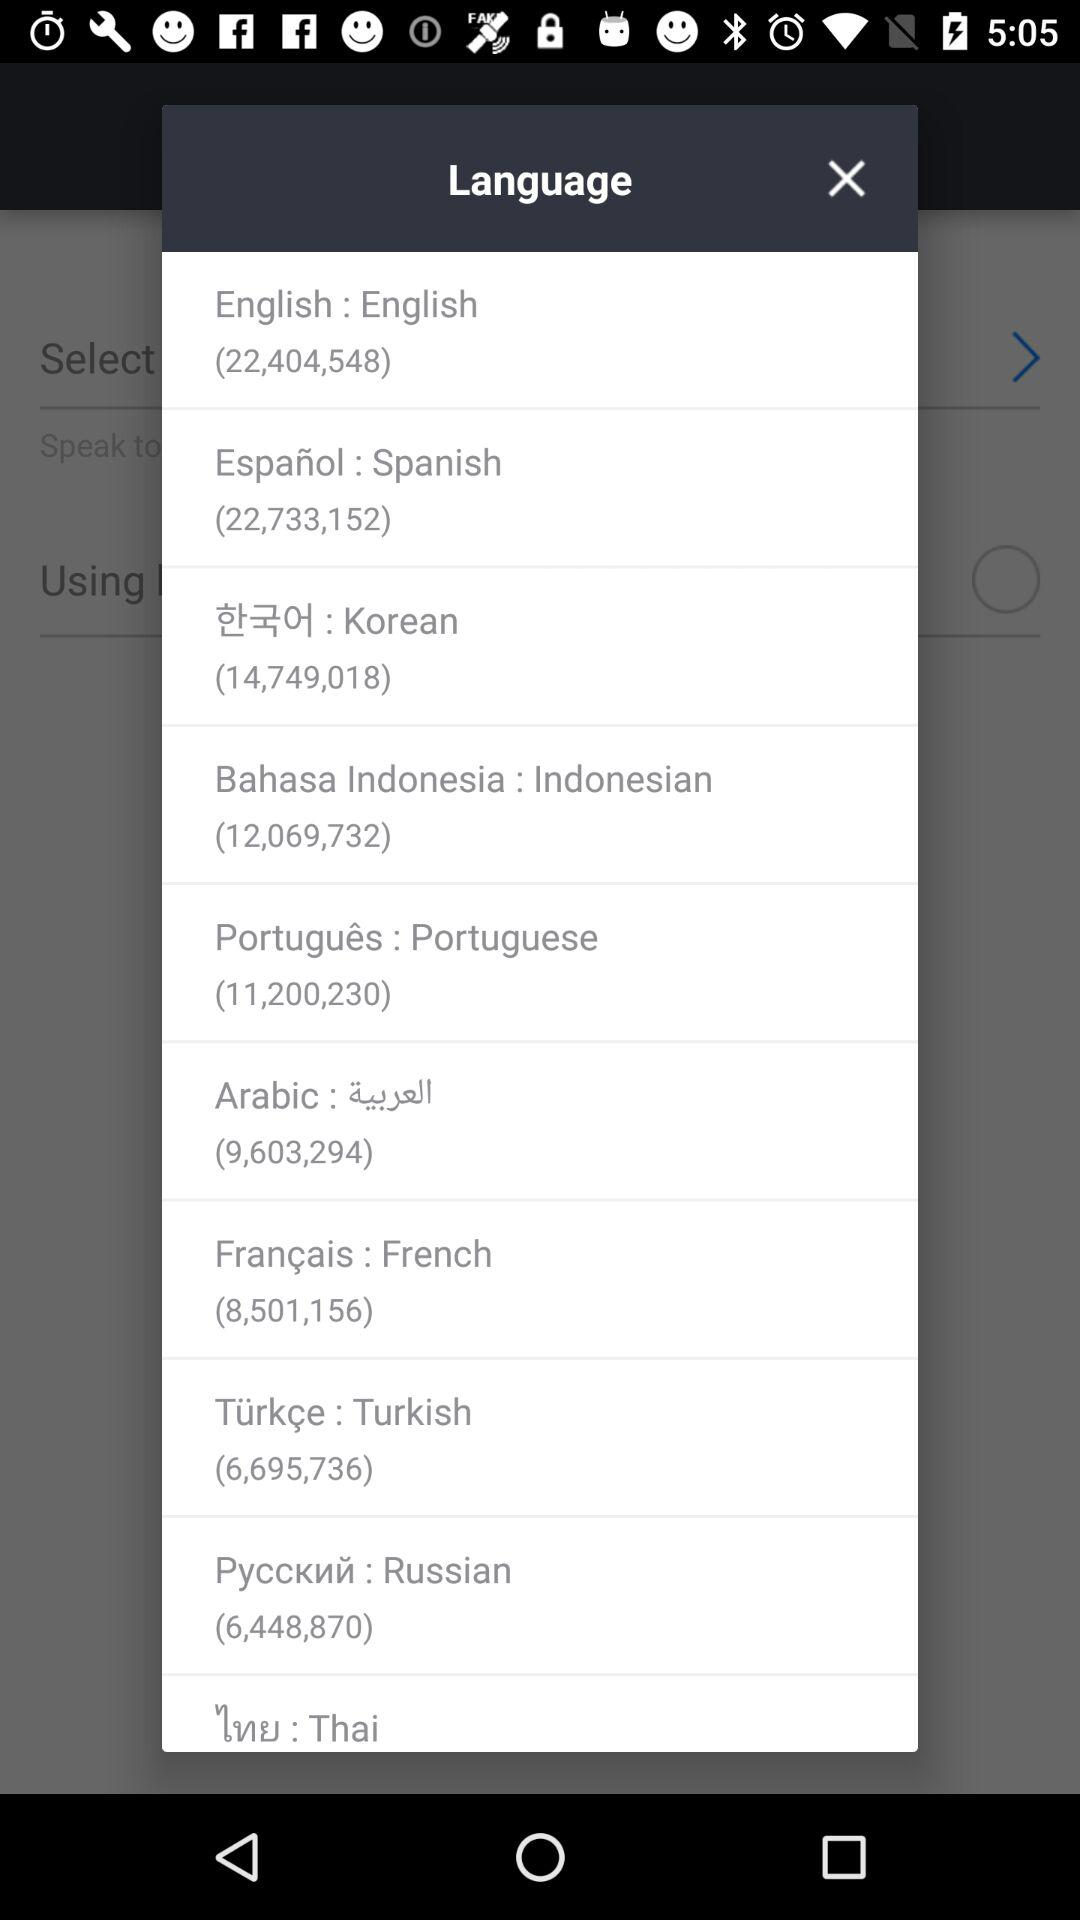Which number is shown in the English language? The number is 22,404,548. 